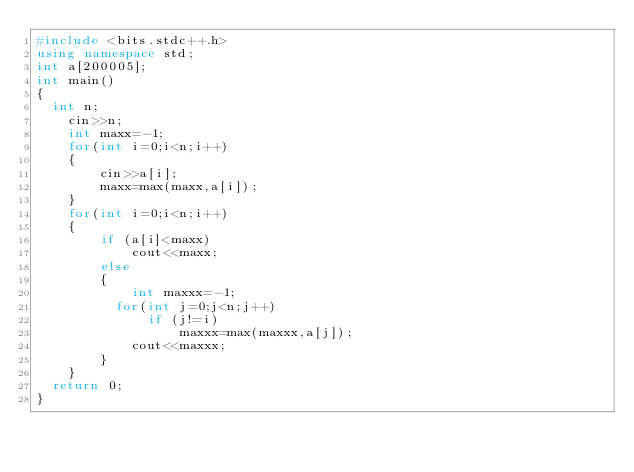Convert code to text. <code><loc_0><loc_0><loc_500><loc_500><_C++_>#include <bits.stdc++.h>
using namespace std;
int a[200005];
int main()
{
	int n;
  	cin>>n;
  	int maxx=-1;
  	for(int i=0;i<n;i++)
    {
      	cin>>a[i];
      	maxx=max(maxx,a[i]);
    }
  	for(int i=0;i<n;i++)
    {
      	if (a[i]<maxx)
          	cout<<maxx;
      	else 
        {
          	int maxxx=-1;
        	for(int j=0;j<n;j++)
             	if (j!=i)
                 	maxxx=max(maxxx,a[j]);
          	cout<<maxxx;
        }
    }
  return 0;
}</code> 